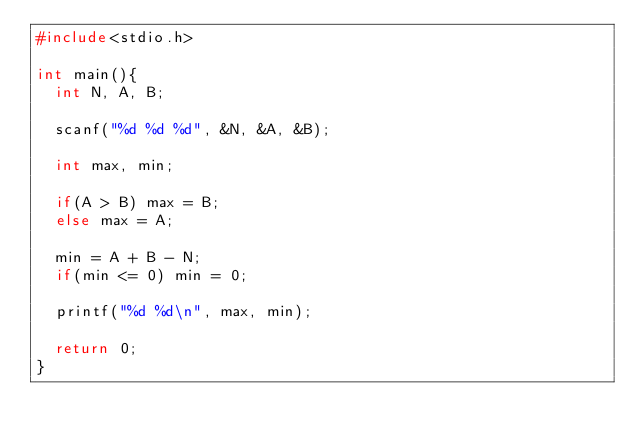Convert code to text. <code><loc_0><loc_0><loc_500><loc_500><_C_>#include<stdio.h>

int main(){
  int N, A, B;

  scanf("%d %d %d", &N, &A, &B);

  int max, min;

  if(A > B) max = B;
  else max = A;

  min = A + B - N;
  if(min <= 0) min = 0;

  printf("%d %d\n", max, min);

  return 0;
}
</code> 